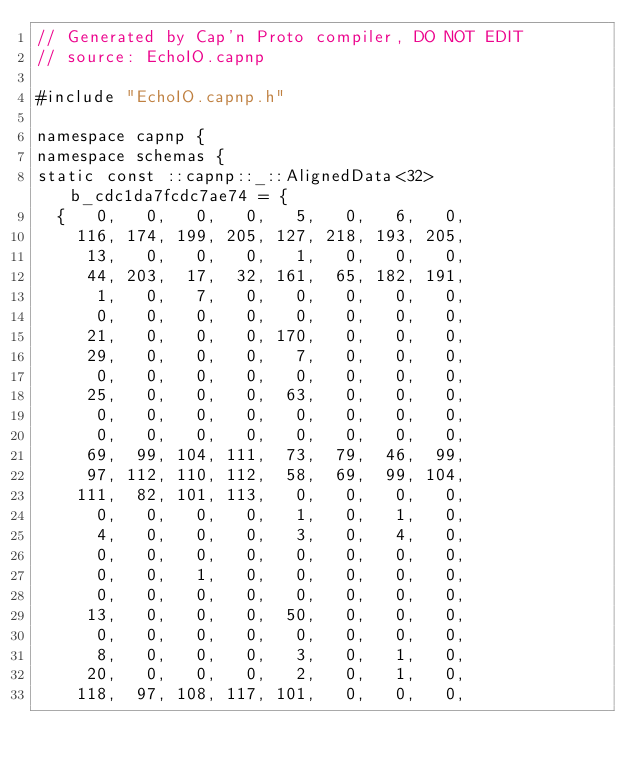Convert code to text. <code><loc_0><loc_0><loc_500><loc_500><_C++_>// Generated by Cap'n Proto compiler, DO NOT EDIT
// source: EchoIO.capnp

#include "EchoIO.capnp.h"

namespace capnp {
namespace schemas {
static const ::capnp::_::AlignedData<32> b_cdc1da7fcdc7ae74 = {
  {   0,   0,   0,   0,   5,   0,   6,   0,
    116, 174, 199, 205, 127, 218, 193, 205,
     13,   0,   0,   0,   1,   0,   0,   0,
     44, 203,  17,  32, 161,  65, 182, 191,
      1,   0,   7,   0,   0,   0,   0,   0,
      0,   0,   0,   0,   0,   0,   0,   0,
     21,   0,   0,   0, 170,   0,   0,   0,
     29,   0,   0,   0,   7,   0,   0,   0,
      0,   0,   0,   0,   0,   0,   0,   0,
     25,   0,   0,   0,  63,   0,   0,   0,
      0,   0,   0,   0,   0,   0,   0,   0,
      0,   0,   0,   0,   0,   0,   0,   0,
     69,  99, 104, 111,  73,  79,  46,  99,
     97, 112, 110, 112,  58,  69,  99, 104,
    111,  82, 101, 113,   0,   0,   0,   0,
      0,   0,   0,   0,   1,   0,   1,   0,
      4,   0,   0,   0,   3,   0,   4,   0,
      0,   0,   0,   0,   0,   0,   0,   0,
      0,   0,   1,   0,   0,   0,   0,   0,
      0,   0,   0,   0,   0,   0,   0,   0,
     13,   0,   0,   0,  50,   0,   0,   0,
      0,   0,   0,   0,   0,   0,   0,   0,
      8,   0,   0,   0,   3,   0,   1,   0,
     20,   0,   0,   0,   2,   0,   1,   0,
    118,  97, 108, 117, 101,   0,   0,   0,</code> 